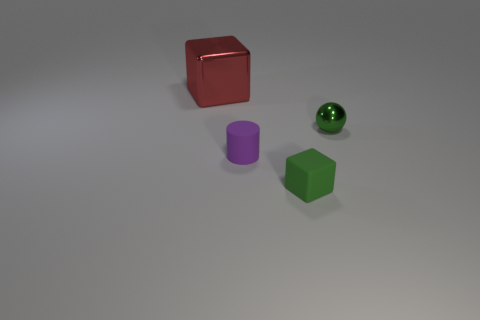Add 4 small purple rubber cylinders. How many objects exist? 8 Subtract 1 green balls. How many objects are left? 3 Subtract all balls. How many objects are left? 3 Subtract 1 balls. How many balls are left? 0 Subtract all yellow cylinders. Subtract all brown blocks. How many cylinders are left? 1 Subtract all brown spheres. How many yellow cylinders are left? 0 Subtract all big brown matte balls. Subtract all red things. How many objects are left? 3 Add 1 purple cylinders. How many purple cylinders are left? 2 Add 3 small metallic things. How many small metallic things exist? 4 